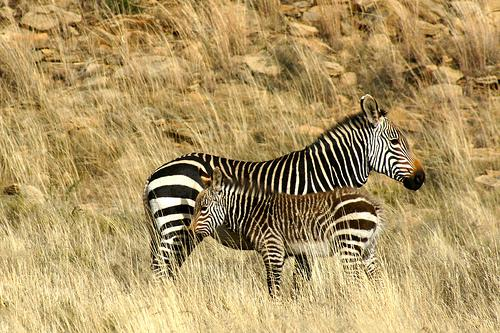What is the unique marking on the adult zebra's nose? The adult zebra has a rusty brown marking on the top of its nose. What is the distinguishing feature of the young zebra's ear? The young zebra's oval ear has a black center bordered in white. Provide a brief description of the primary subjects of the image. Two zebras, an adult and a young one, are standing in a field filled with brown tall grass and rocks. How many zebras can be seen in the image, and what are their age groups? There are two zebras in the image, one adult and one young zebra. Describe the pattern found on the zebras' body and neck. The zebras have bold and thick black and white vertical stripes along their neck and body. Mention a notable aspect of the young zebra's underbelly. The young zebra has a rectangular patch of white in its underbelly. Describe the prominent features of the zebras in this image. The zebras have striking black and white stripes, big ears, oval eyes, and a white and black mane. Identify the elements in the image representing the zebras' environment. The environment consists of brown tall grass, gray and tan rocks, and some white grass near the zebras. Which direction are the zebras facing in the image? The zebras are facing opposite directions. What is the predominant color of the grass in the field surrounding the zebras? The predominant color of the grass is brown. Observe the group of penguins playing around in the background. No, it's not mentioned in the image. Can you spot the rainbow-colored unicorn standing beside the zebras? Unicorns are mythical creatures and do not exist in reality. Moreover, there is no mention of rainbows or other colorful objects. Search for the hidden treasure chest buried in the field. The given objects in the image are zebras and natural elements like rocks or grass but do not include any human-made objects like treasure chests or hidden riches. 